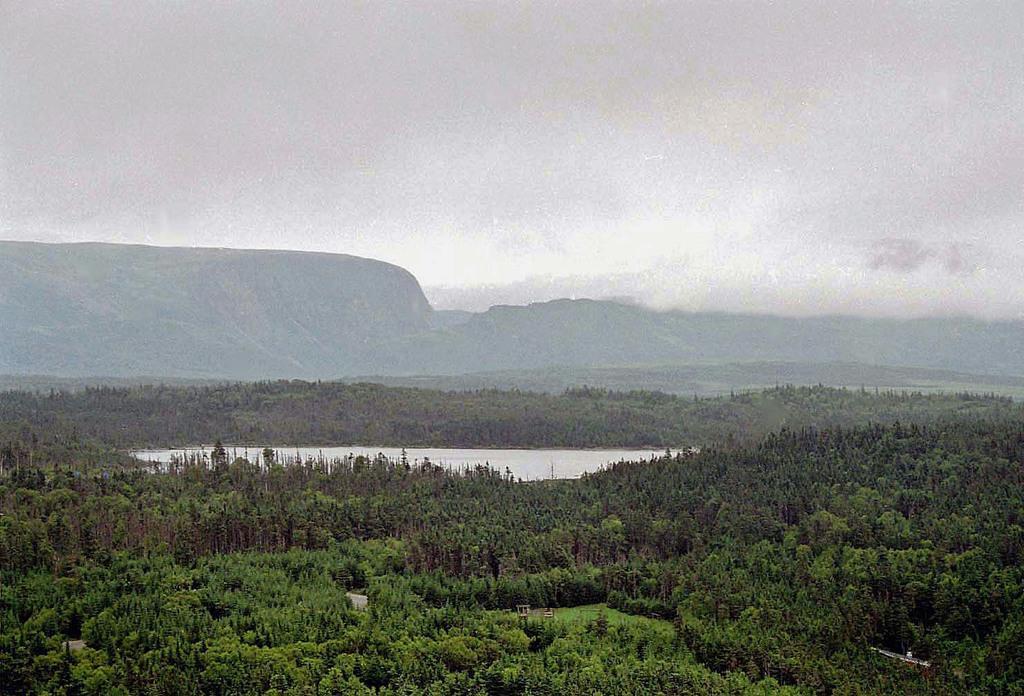In one or two sentences, can you explain what this image depicts? This is the picture of a mountain. In this image there are trees in the foreground. In the middle of the image there is water. At the back there are mountains. At the top there is sky. 